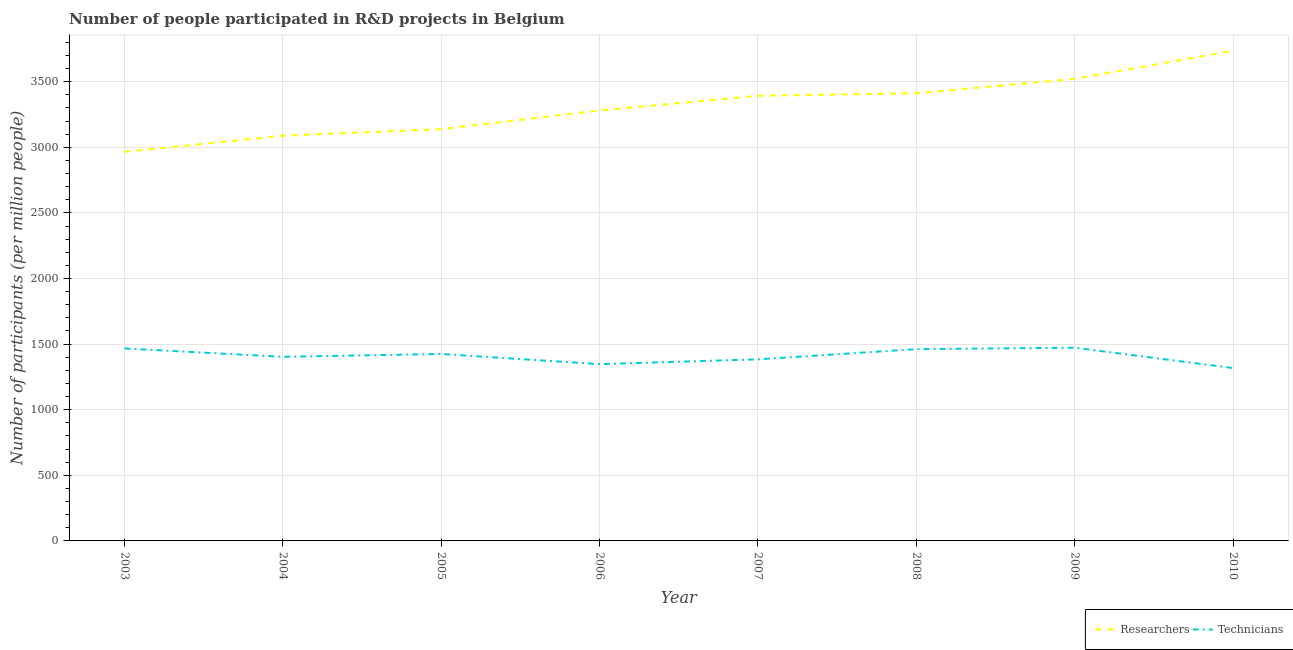Is the number of lines equal to the number of legend labels?
Ensure brevity in your answer.  Yes. What is the number of technicians in 2010?
Give a very brief answer. 1317.54. Across all years, what is the maximum number of technicians?
Your answer should be compact. 1472.61. Across all years, what is the minimum number of technicians?
Provide a short and direct response. 1317.54. In which year was the number of researchers maximum?
Offer a terse response. 2010. What is the total number of technicians in the graph?
Give a very brief answer. 1.13e+04. What is the difference between the number of researchers in 2003 and that in 2004?
Your answer should be very brief. -122.58. What is the difference between the number of technicians in 2008 and the number of researchers in 2005?
Your answer should be very brief. -1676.87. What is the average number of technicians per year?
Ensure brevity in your answer.  1409.7. In the year 2006, what is the difference between the number of researchers and number of technicians?
Give a very brief answer. 1933.19. What is the ratio of the number of researchers in 2007 to that in 2009?
Your answer should be compact. 0.96. Is the difference between the number of researchers in 2003 and 2004 greater than the difference between the number of technicians in 2003 and 2004?
Your answer should be compact. No. What is the difference between the highest and the second highest number of technicians?
Your answer should be compact. 5.79. What is the difference between the highest and the lowest number of researchers?
Your answer should be very brief. 770.48. In how many years, is the number of researchers greater than the average number of researchers taken over all years?
Offer a very short reply. 4. Is the number of technicians strictly less than the number of researchers over the years?
Keep it short and to the point. Yes. How many lines are there?
Provide a succinct answer. 2. What is the difference between two consecutive major ticks on the Y-axis?
Your response must be concise. 500. Where does the legend appear in the graph?
Offer a terse response. Bottom right. How many legend labels are there?
Make the answer very short. 2. What is the title of the graph?
Keep it short and to the point. Number of people participated in R&D projects in Belgium. What is the label or title of the X-axis?
Provide a short and direct response. Year. What is the label or title of the Y-axis?
Your answer should be very brief. Number of participants (per million people). What is the Number of participants (per million people) of Researchers in 2003?
Your response must be concise. 2965.34. What is the Number of participants (per million people) of Technicians in 2003?
Your response must be concise. 1466.82. What is the Number of participants (per million people) in Researchers in 2004?
Make the answer very short. 3087.91. What is the Number of participants (per million people) of Technicians in 2004?
Ensure brevity in your answer.  1403.12. What is the Number of participants (per million people) in Researchers in 2005?
Your answer should be very brief. 3138.4. What is the Number of participants (per million people) in Technicians in 2005?
Offer a very short reply. 1424.67. What is the Number of participants (per million people) in Researchers in 2006?
Provide a short and direct response. 3280.55. What is the Number of participants (per million people) in Technicians in 2006?
Offer a terse response. 1347.37. What is the Number of participants (per million people) of Researchers in 2007?
Your answer should be compact. 3392.72. What is the Number of participants (per million people) of Technicians in 2007?
Offer a terse response. 1383.94. What is the Number of participants (per million people) of Researchers in 2008?
Give a very brief answer. 3411.63. What is the Number of participants (per million people) in Technicians in 2008?
Offer a very short reply. 1461.53. What is the Number of participants (per million people) in Researchers in 2009?
Make the answer very short. 3521.66. What is the Number of participants (per million people) in Technicians in 2009?
Your answer should be very brief. 1472.61. What is the Number of participants (per million people) of Researchers in 2010?
Ensure brevity in your answer.  3735.82. What is the Number of participants (per million people) in Technicians in 2010?
Give a very brief answer. 1317.54. Across all years, what is the maximum Number of participants (per million people) in Researchers?
Your response must be concise. 3735.82. Across all years, what is the maximum Number of participants (per million people) in Technicians?
Offer a very short reply. 1472.61. Across all years, what is the minimum Number of participants (per million people) in Researchers?
Your response must be concise. 2965.34. Across all years, what is the minimum Number of participants (per million people) of Technicians?
Offer a terse response. 1317.54. What is the total Number of participants (per million people) of Researchers in the graph?
Offer a terse response. 2.65e+04. What is the total Number of participants (per million people) of Technicians in the graph?
Keep it short and to the point. 1.13e+04. What is the difference between the Number of participants (per million people) of Researchers in 2003 and that in 2004?
Your answer should be compact. -122.58. What is the difference between the Number of participants (per million people) in Technicians in 2003 and that in 2004?
Your answer should be very brief. 63.7. What is the difference between the Number of participants (per million people) in Researchers in 2003 and that in 2005?
Offer a very short reply. -173.06. What is the difference between the Number of participants (per million people) of Technicians in 2003 and that in 2005?
Keep it short and to the point. 42.14. What is the difference between the Number of participants (per million people) in Researchers in 2003 and that in 2006?
Provide a short and direct response. -315.21. What is the difference between the Number of participants (per million people) in Technicians in 2003 and that in 2006?
Make the answer very short. 119.45. What is the difference between the Number of participants (per million people) in Researchers in 2003 and that in 2007?
Keep it short and to the point. -427.38. What is the difference between the Number of participants (per million people) of Technicians in 2003 and that in 2007?
Ensure brevity in your answer.  82.88. What is the difference between the Number of participants (per million people) of Researchers in 2003 and that in 2008?
Ensure brevity in your answer.  -446.29. What is the difference between the Number of participants (per million people) of Technicians in 2003 and that in 2008?
Give a very brief answer. 5.28. What is the difference between the Number of participants (per million people) of Researchers in 2003 and that in 2009?
Your answer should be very brief. -556.32. What is the difference between the Number of participants (per million people) of Technicians in 2003 and that in 2009?
Your response must be concise. -5.79. What is the difference between the Number of participants (per million people) in Researchers in 2003 and that in 2010?
Make the answer very short. -770.48. What is the difference between the Number of participants (per million people) of Technicians in 2003 and that in 2010?
Give a very brief answer. 149.28. What is the difference between the Number of participants (per million people) in Researchers in 2004 and that in 2005?
Your response must be concise. -50.49. What is the difference between the Number of participants (per million people) in Technicians in 2004 and that in 2005?
Make the answer very short. -21.56. What is the difference between the Number of participants (per million people) of Researchers in 2004 and that in 2006?
Provide a succinct answer. -192.64. What is the difference between the Number of participants (per million people) in Technicians in 2004 and that in 2006?
Keep it short and to the point. 55.75. What is the difference between the Number of participants (per million people) in Researchers in 2004 and that in 2007?
Provide a short and direct response. -304.8. What is the difference between the Number of participants (per million people) in Technicians in 2004 and that in 2007?
Your answer should be compact. 19.18. What is the difference between the Number of participants (per million people) in Researchers in 2004 and that in 2008?
Your answer should be very brief. -323.71. What is the difference between the Number of participants (per million people) in Technicians in 2004 and that in 2008?
Make the answer very short. -58.42. What is the difference between the Number of participants (per million people) of Researchers in 2004 and that in 2009?
Provide a short and direct response. -433.74. What is the difference between the Number of participants (per million people) of Technicians in 2004 and that in 2009?
Give a very brief answer. -69.5. What is the difference between the Number of participants (per million people) of Researchers in 2004 and that in 2010?
Provide a short and direct response. -647.91. What is the difference between the Number of participants (per million people) of Technicians in 2004 and that in 2010?
Keep it short and to the point. 85.58. What is the difference between the Number of participants (per million people) in Researchers in 2005 and that in 2006?
Ensure brevity in your answer.  -142.15. What is the difference between the Number of participants (per million people) of Technicians in 2005 and that in 2006?
Offer a terse response. 77.31. What is the difference between the Number of participants (per million people) of Researchers in 2005 and that in 2007?
Provide a short and direct response. -254.32. What is the difference between the Number of participants (per million people) in Technicians in 2005 and that in 2007?
Your answer should be compact. 40.74. What is the difference between the Number of participants (per million people) of Researchers in 2005 and that in 2008?
Your response must be concise. -273.23. What is the difference between the Number of participants (per million people) in Technicians in 2005 and that in 2008?
Offer a very short reply. -36.86. What is the difference between the Number of participants (per million people) in Researchers in 2005 and that in 2009?
Your answer should be compact. -383.26. What is the difference between the Number of participants (per million people) in Technicians in 2005 and that in 2009?
Your answer should be compact. -47.94. What is the difference between the Number of participants (per million people) of Researchers in 2005 and that in 2010?
Provide a succinct answer. -597.42. What is the difference between the Number of participants (per million people) of Technicians in 2005 and that in 2010?
Give a very brief answer. 107.14. What is the difference between the Number of participants (per million people) of Researchers in 2006 and that in 2007?
Your answer should be very brief. -112.16. What is the difference between the Number of participants (per million people) in Technicians in 2006 and that in 2007?
Offer a terse response. -36.57. What is the difference between the Number of participants (per million people) of Researchers in 2006 and that in 2008?
Your answer should be very brief. -131.08. What is the difference between the Number of participants (per million people) of Technicians in 2006 and that in 2008?
Keep it short and to the point. -114.17. What is the difference between the Number of participants (per million people) in Researchers in 2006 and that in 2009?
Your answer should be very brief. -241.1. What is the difference between the Number of participants (per million people) of Technicians in 2006 and that in 2009?
Offer a very short reply. -125.25. What is the difference between the Number of participants (per million people) in Researchers in 2006 and that in 2010?
Keep it short and to the point. -455.27. What is the difference between the Number of participants (per million people) in Technicians in 2006 and that in 2010?
Keep it short and to the point. 29.83. What is the difference between the Number of participants (per million people) of Researchers in 2007 and that in 2008?
Give a very brief answer. -18.91. What is the difference between the Number of participants (per million people) of Technicians in 2007 and that in 2008?
Provide a short and direct response. -77.6. What is the difference between the Number of participants (per million people) in Researchers in 2007 and that in 2009?
Ensure brevity in your answer.  -128.94. What is the difference between the Number of participants (per million people) in Technicians in 2007 and that in 2009?
Offer a very short reply. -88.68. What is the difference between the Number of participants (per million people) in Researchers in 2007 and that in 2010?
Keep it short and to the point. -343.11. What is the difference between the Number of participants (per million people) in Technicians in 2007 and that in 2010?
Offer a very short reply. 66.4. What is the difference between the Number of participants (per million people) in Researchers in 2008 and that in 2009?
Give a very brief answer. -110.03. What is the difference between the Number of participants (per million people) of Technicians in 2008 and that in 2009?
Provide a succinct answer. -11.08. What is the difference between the Number of participants (per million people) of Researchers in 2008 and that in 2010?
Give a very brief answer. -324.2. What is the difference between the Number of participants (per million people) of Technicians in 2008 and that in 2010?
Keep it short and to the point. 144. What is the difference between the Number of participants (per million people) in Researchers in 2009 and that in 2010?
Make the answer very short. -214.17. What is the difference between the Number of participants (per million people) of Technicians in 2009 and that in 2010?
Give a very brief answer. 155.08. What is the difference between the Number of participants (per million people) of Researchers in 2003 and the Number of participants (per million people) of Technicians in 2004?
Your response must be concise. 1562.22. What is the difference between the Number of participants (per million people) in Researchers in 2003 and the Number of participants (per million people) in Technicians in 2005?
Provide a short and direct response. 1540.67. What is the difference between the Number of participants (per million people) in Researchers in 2003 and the Number of participants (per million people) in Technicians in 2006?
Your response must be concise. 1617.97. What is the difference between the Number of participants (per million people) of Researchers in 2003 and the Number of participants (per million people) of Technicians in 2007?
Provide a succinct answer. 1581.4. What is the difference between the Number of participants (per million people) in Researchers in 2003 and the Number of participants (per million people) in Technicians in 2008?
Keep it short and to the point. 1503.8. What is the difference between the Number of participants (per million people) of Researchers in 2003 and the Number of participants (per million people) of Technicians in 2009?
Offer a terse response. 1492.73. What is the difference between the Number of participants (per million people) of Researchers in 2003 and the Number of participants (per million people) of Technicians in 2010?
Give a very brief answer. 1647.8. What is the difference between the Number of participants (per million people) of Researchers in 2004 and the Number of participants (per million people) of Technicians in 2005?
Ensure brevity in your answer.  1663.24. What is the difference between the Number of participants (per million people) of Researchers in 2004 and the Number of participants (per million people) of Technicians in 2006?
Give a very brief answer. 1740.55. What is the difference between the Number of participants (per million people) of Researchers in 2004 and the Number of participants (per million people) of Technicians in 2007?
Ensure brevity in your answer.  1703.98. What is the difference between the Number of participants (per million people) of Researchers in 2004 and the Number of participants (per million people) of Technicians in 2008?
Your answer should be very brief. 1626.38. What is the difference between the Number of participants (per million people) of Researchers in 2004 and the Number of participants (per million people) of Technicians in 2009?
Offer a very short reply. 1615.3. What is the difference between the Number of participants (per million people) in Researchers in 2004 and the Number of participants (per million people) in Technicians in 2010?
Your response must be concise. 1770.38. What is the difference between the Number of participants (per million people) in Researchers in 2005 and the Number of participants (per million people) in Technicians in 2006?
Provide a succinct answer. 1791.04. What is the difference between the Number of participants (per million people) of Researchers in 2005 and the Number of participants (per million people) of Technicians in 2007?
Provide a succinct answer. 1754.46. What is the difference between the Number of participants (per million people) in Researchers in 2005 and the Number of participants (per million people) in Technicians in 2008?
Provide a succinct answer. 1676.87. What is the difference between the Number of participants (per million people) in Researchers in 2005 and the Number of participants (per million people) in Technicians in 2009?
Keep it short and to the point. 1665.79. What is the difference between the Number of participants (per million people) of Researchers in 2005 and the Number of participants (per million people) of Technicians in 2010?
Give a very brief answer. 1820.86. What is the difference between the Number of participants (per million people) of Researchers in 2006 and the Number of participants (per million people) of Technicians in 2007?
Offer a terse response. 1896.62. What is the difference between the Number of participants (per million people) in Researchers in 2006 and the Number of participants (per million people) in Technicians in 2008?
Offer a terse response. 1819.02. What is the difference between the Number of participants (per million people) of Researchers in 2006 and the Number of participants (per million people) of Technicians in 2009?
Your answer should be very brief. 1807.94. What is the difference between the Number of participants (per million people) in Researchers in 2006 and the Number of participants (per million people) in Technicians in 2010?
Give a very brief answer. 1963.02. What is the difference between the Number of participants (per million people) in Researchers in 2007 and the Number of participants (per million people) in Technicians in 2008?
Provide a succinct answer. 1931.18. What is the difference between the Number of participants (per million people) in Researchers in 2007 and the Number of participants (per million people) in Technicians in 2009?
Your answer should be very brief. 1920.1. What is the difference between the Number of participants (per million people) in Researchers in 2007 and the Number of participants (per million people) in Technicians in 2010?
Provide a succinct answer. 2075.18. What is the difference between the Number of participants (per million people) in Researchers in 2008 and the Number of participants (per million people) in Technicians in 2009?
Offer a terse response. 1939.02. What is the difference between the Number of participants (per million people) in Researchers in 2008 and the Number of participants (per million people) in Technicians in 2010?
Keep it short and to the point. 2094.09. What is the difference between the Number of participants (per million people) in Researchers in 2009 and the Number of participants (per million people) in Technicians in 2010?
Ensure brevity in your answer.  2204.12. What is the average Number of participants (per million people) of Researchers per year?
Provide a succinct answer. 3316.75. What is the average Number of participants (per million people) of Technicians per year?
Provide a short and direct response. 1409.7. In the year 2003, what is the difference between the Number of participants (per million people) in Researchers and Number of participants (per million people) in Technicians?
Your answer should be very brief. 1498.52. In the year 2004, what is the difference between the Number of participants (per million people) of Researchers and Number of participants (per million people) of Technicians?
Offer a very short reply. 1684.8. In the year 2005, what is the difference between the Number of participants (per million people) in Researchers and Number of participants (per million people) in Technicians?
Provide a succinct answer. 1713.73. In the year 2006, what is the difference between the Number of participants (per million people) in Researchers and Number of participants (per million people) in Technicians?
Ensure brevity in your answer.  1933.19. In the year 2007, what is the difference between the Number of participants (per million people) of Researchers and Number of participants (per million people) of Technicians?
Your response must be concise. 2008.78. In the year 2008, what is the difference between the Number of participants (per million people) of Researchers and Number of participants (per million people) of Technicians?
Give a very brief answer. 1950.09. In the year 2009, what is the difference between the Number of participants (per million people) in Researchers and Number of participants (per million people) in Technicians?
Offer a very short reply. 2049.04. In the year 2010, what is the difference between the Number of participants (per million people) in Researchers and Number of participants (per million people) in Technicians?
Give a very brief answer. 2418.29. What is the ratio of the Number of participants (per million people) in Researchers in 2003 to that in 2004?
Ensure brevity in your answer.  0.96. What is the ratio of the Number of participants (per million people) in Technicians in 2003 to that in 2004?
Provide a short and direct response. 1.05. What is the ratio of the Number of participants (per million people) of Researchers in 2003 to that in 2005?
Keep it short and to the point. 0.94. What is the ratio of the Number of participants (per million people) of Technicians in 2003 to that in 2005?
Make the answer very short. 1.03. What is the ratio of the Number of participants (per million people) of Researchers in 2003 to that in 2006?
Give a very brief answer. 0.9. What is the ratio of the Number of participants (per million people) in Technicians in 2003 to that in 2006?
Your answer should be very brief. 1.09. What is the ratio of the Number of participants (per million people) of Researchers in 2003 to that in 2007?
Your response must be concise. 0.87. What is the ratio of the Number of participants (per million people) in Technicians in 2003 to that in 2007?
Your answer should be compact. 1.06. What is the ratio of the Number of participants (per million people) of Researchers in 2003 to that in 2008?
Make the answer very short. 0.87. What is the ratio of the Number of participants (per million people) of Researchers in 2003 to that in 2009?
Your answer should be very brief. 0.84. What is the ratio of the Number of participants (per million people) in Researchers in 2003 to that in 2010?
Your answer should be compact. 0.79. What is the ratio of the Number of participants (per million people) of Technicians in 2003 to that in 2010?
Your response must be concise. 1.11. What is the ratio of the Number of participants (per million people) of Researchers in 2004 to that in 2005?
Make the answer very short. 0.98. What is the ratio of the Number of participants (per million people) in Technicians in 2004 to that in 2005?
Give a very brief answer. 0.98. What is the ratio of the Number of participants (per million people) in Researchers in 2004 to that in 2006?
Ensure brevity in your answer.  0.94. What is the ratio of the Number of participants (per million people) of Technicians in 2004 to that in 2006?
Offer a terse response. 1.04. What is the ratio of the Number of participants (per million people) of Researchers in 2004 to that in 2007?
Your response must be concise. 0.91. What is the ratio of the Number of participants (per million people) in Technicians in 2004 to that in 2007?
Your response must be concise. 1.01. What is the ratio of the Number of participants (per million people) in Researchers in 2004 to that in 2008?
Offer a terse response. 0.91. What is the ratio of the Number of participants (per million people) of Technicians in 2004 to that in 2008?
Keep it short and to the point. 0.96. What is the ratio of the Number of participants (per million people) of Researchers in 2004 to that in 2009?
Ensure brevity in your answer.  0.88. What is the ratio of the Number of participants (per million people) of Technicians in 2004 to that in 2009?
Provide a succinct answer. 0.95. What is the ratio of the Number of participants (per million people) of Researchers in 2004 to that in 2010?
Your answer should be very brief. 0.83. What is the ratio of the Number of participants (per million people) in Technicians in 2004 to that in 2010?
Ensure brevity in your answer.  1.06. What is the ratio of the Number of participants (per million people) in Researchers in 2005 to that in 2006?
Your answer should be compact. 0.96. What is the ratio of the Number of participants (per million people) of Technicians in 2005 to that in 2006?
Give a very brief answer. 1.06. What is the ratio of the Number of participants (per million people) of Researchers in 2005 to that in 2007?
Provide a succinct answer. 0.93. What is the ratio of the Number of participants (per million people) in Technicians in 2005 to that in 2007?
Offer a terse response. 1.03. What is the ratio of the Number of participants (per million people) of Researchers in 2005 to that in 2008?
Make the answer very short. 0.92. What is the ratio of the Number of participants (per million people) in Technicians in 2005 to that in 2008?
Offer a terse response. 0.97. What is the ratio of the Number of participants (per million people) in Researchers in 2005 to that in 2009?
Provide a short and direct response. 0.89. What is the ratio of the Number of participants (per million people) of Technicians in 2005 to that in 2009?
Your answer should be compact. 0.97. What is the ratio of the Number of participants (per million people) in Researchers in 2005 to that in 2010?
Ensure brevity in your answer.  0.84. What is the ratio of the Number of participants (per million people) of Technicians in 2005 to that in 2010?
Make the answer very short. 1.08. What is the ratio of the Number of participants (per million people) in Researchers in 2006 to that in 2007?
Provide a succinct answer. 0.97. What is the ratio of the Number of participants (per million people) of Technicians in 2006 to that in 2007?
Your answer should be very brief. 0.97. What is the ratio of the Number of participants (per million people) of Researchers in 2006 to that in 2008?
Make the answer very short. 0.96. What is the ratio of the Number of participants (per million people) of Technicians in 2006 to that in 2008?
Provide a succinct answer. 0.92. What is the ratio of the Number of participants (per million people) of Researchers in 2006 to that in 2009?
Offer a very short reply. 0.93. What is the ratio of the Number of participants (per million people) of Technicians in 2006 to that in 2009?
Offer a terse response. 0.91. What is the ratio of the Number of participants (per million people) in Researchers in 2006 to that in 2010?
Give a very brief answer. 0.88. What is the ratio of the Number of participants (per million people) of Technicians in 2006 to that in 2010?
Your answer should be compact. 1.02. What is the ratio of the Number of participants (per million people) of Technicians in 2007 to that in 2008?
Provide a short and direct response. 0.95. What is the ratio of the Number of participants (per million people) of Researchers in 2007 to that in 2009?
Your answer should be compact. 0.96. What is the ratio of the Number of participants (per million people) of Technicians in 2007 to that in 2009?
Offer a very short reply. 0.94. What is the ratio of the Number of participants (per million people) in Researchers in 2007 to that in 2010?
Your answer should be very brief. 0.91. What is the ratio of the Number of participants (per million people) of Technicians in 2007 to that in 2010?
Your answer should be very brief. 1.05. What is the ratio of the Number of participants (per million people) in Researchers in 2008 to that in 2009?
Keep it short and to the point. 0.97. What is the ratio of the Number of participants (per million people) of Technicians in 2008 to that in 2009?
Give a very brief answer. 0.99. What is the ratio of the Number of participants (per million people) in Researchers in 2008 to that in 2010?
Provide a short and direct response. 0.91. What is the ratio of the Number of participants (per million people) of Technicians in 2008 to that in 2010?
Provide a short and direct response. 1.11. What is the ratio of the Number of participants (per million people) in Researchers in 2009 to that in 2010?
Provide a succinct answer. 0.94. What is the ratio of the Number of participants (per million people) of Technicians in 2009 to that in 2010?
Provide a succinct answer. 1.12. What is the difference between the highest and the second highest Number of participants (per million people) in Researchers?
Provide a succinct answer. 214.17. What is the difference between the highest and the second highest Number of participants (per million people) in Technicians?
Provide a short and direct response. 5.79. What is the difference between the highest and the lowest Number of participants (per million people) of Researchers?
Ensure brevity in your answer.  770.48. What is the difference between the highest and the lowest Number of participants (per million people) of Technicians?
Offer a terse response. 155.08. 